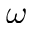Convert formula to latex. <formula><loc_0><loc_0><loc_500><loc_500>\omega</formula> 